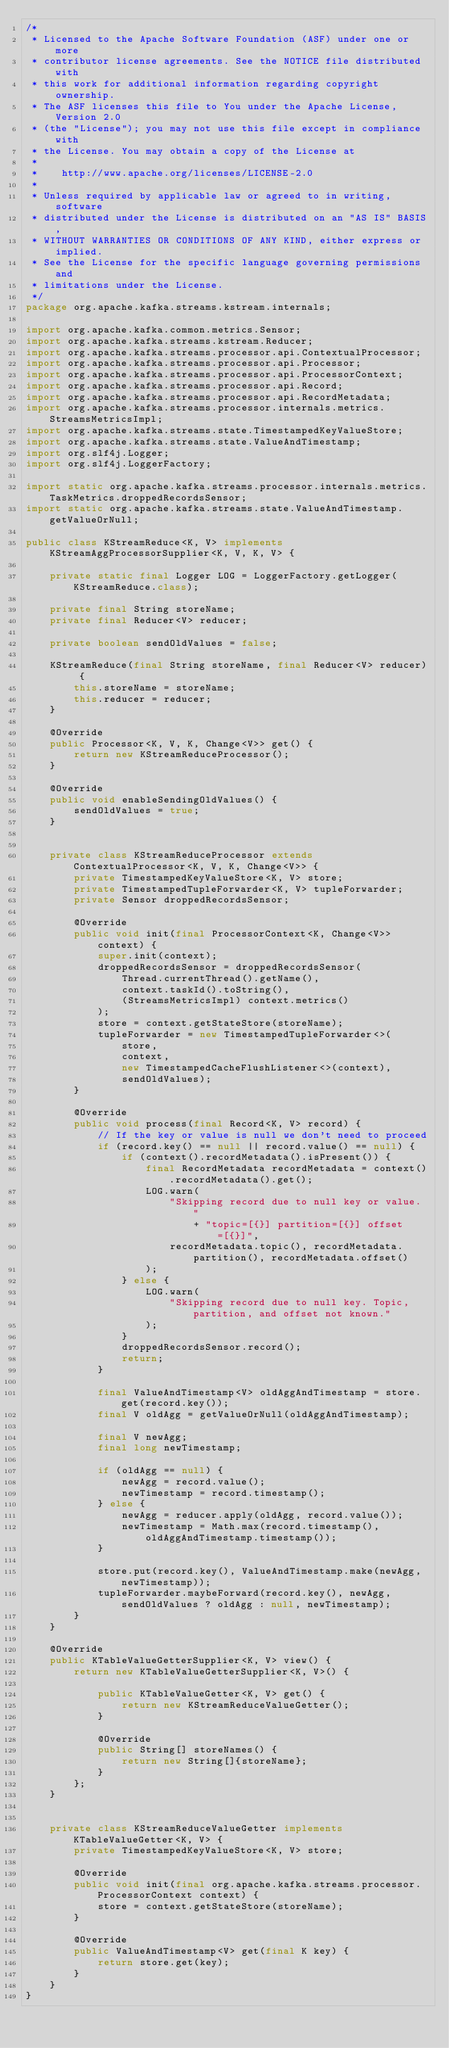Convert code to text. <code><loc_0><loc_0><loc_500><loc_500><_Java_>/*
 * Licensed to the Apache Software Foundation (ASF) under one or more
 * contributor license agreements. See the NOTICE file distributed with
 * this work for additional information regarding copyright ownership.
 * The ASF licenses this file to You under the Apache License, Version 2.0
 * (the "License"); you may not use this file except in compliance with
 * the License. You may obtain a copy of the License at
 *
 *    http://www.apache.org/licenses/LICENSE-2.0
 *
 * Unless required by applicable law or agreed to in writing, software
 * distributed under the License is distributed on an "AS IS" BASIS,
 * WITHOUT WARRANTIES OR CONDITIONS OF ANY KIND, either express or implied.
 * See the License for the specific language governing permissions and
 * limitations under the License.
 */
package org.apache.kafka.streams.kstream.internals;

import org.apache.kafka.common.metrics.Sensor;
import org.apache.kafka.streams.kstream.Reducer;
import org.apache.kafka.streams.processor.api.ContextualProcessor;
import org.apache.kafka.streams.processor.api.Processor;
import org.apache.kafka.streams.processor.api.ProcessorContext;
import org.apache.kafka.streams.processor.api.Record;
import org.apache.kafka.streams.processor.api.RecordMetadata;
import org.apache.kafka.streams.processor.internals.metrics.StreamsMetricsImpl;
import org.apache.kafka.streams.state.TimestampedKeyValueStore;
import org.apache.kafka.streams.state.ValueAndTimestamp;
import org.slf4j.Logger;
import org.slf4j.LoggerFactory;

import static org.apache.kafka.streams.processor.internals.metrics.TaskMetrics.droppedRecordsSensor;
import static org.apache.kafka.streams.state.ValueAndTimestamp.getValueOrNull;

public class KStreamReduce<K, V> implements KStreamAggProcessorSupplier<K, V, K, V> {

    private static final Logger LOG = LoggerFactory.getLogger(KStreamReduce.class);

    private final String storeName;
    private final Reducer<V> reducer;

    private boolean sendOldValues = false;

    KStreamReduce(final String storeName, final Reducer<V> reducer) {
        this.storeName = storeName;
        this.reducer = reducer;
    }

    @Override
    public Processor<K, V, K, Change<V>> get() {
        return new KStreamReduceProcessor();
    }

    @Override
    public void enableSendingOldValues() {
        sendOldValues = true;
    }


    private class KStreamReduceProcessor extends ContextualProcessor<K, V, K, Change<V>> {
        private TimestampedKeyValueStore<K, V> store;
        private TimestampedTupleForwarder<K, V> tupleForwarder;
        private Sensor droppedRecordsSensor;

        @Override
        public void init(final ProcessorContext<K, Change<V>> context) {
            super.init(context);
            droppedRecordsSensor = droppedRecordsSensor(
                Thread.currentThread().getName(),
                context.taskId().toString(),
                (StreamsMetricsImpl) context.metrics()
            );
            store = context.getStateStore(storeName);
            tupleForwarder = new TimestampedTupleForwarder<>(
                store,
                context,
                new TimestampedCacheFlushListener<>(context),
                sendOldValues);
        }

        @Override
        public void process(final Record<K, V> record) {
            // If the key or value is null we don't need to proceed
            if (record.key() == null || record.value() == null) {
                if (context().recordMetadata().isPresent()) {
                    final RecordMetadata recordMetadata = context().recordMetadata().get();
                    LOG.warn(
                        "Skipping record due to null key or value. "
                            + "topic=[{}] partition=[{}] offset=[{}]",
                        recordMetadata.topic(), recordMetadata.partition(), recordMetadata.offset()
                    );
                } else {
                    LOG.warn(
                        "Skipping record due to null key. Topic, partition, and offset not known."
                    );
                }
                droppedRecordsSensor.record();
                return;
            }

            final ValueAndTimestamp<V> oldAggAndTimestamp = store.get(record.key());
            final V oldAgg = getValueOrNull(oldAggAndTimestamp);

            final V newAgg;
            final long newTimestamp;

            if (oldAgg == null) {
                newAgg = record.value();
                newTimestamp = record.timestamp();
            } else {
                newAgg = reducer.apply(oldAgg, record.value());
                newTimestamp = Math.max(record.timestamp(), oldAggAndTimestamp.timestamp());
            }

            store.put(record.key(), ValueAndTimestamp.make(newAgg, newTimestamp));
            tupleForwarder.maybeForward(record.key(), newAgg, sendOldValues ? oldAgg : null, newTimestamp);
        }
    }

    @Override
    public KTableValueGetterSupplier<K, V> view() {
        return new KTableValueGetterSupplier<K, V>() {

            public KTableValueGetter<K, V> get() {
                return new KStreamReduceValueGetter();
            }

            @Override
            public String[] storeNames() {
                return new String[]{storeName};
            }
        };
    }


    private class KStreamReduceValueGetter implements KTableValueGetter<K, V> {
        private TimestampedKeyValueStore<K, V> store;

        @Override
        public void init(final org.apache.kafka.streams.processor.ProcessorContext context) {
            store = context.getStateStore(storeName);
        }

        @Override
        public ValueAndTimestamp<V> get(final K key) {
            return store.get(key);
        }
    }
}

</code> 